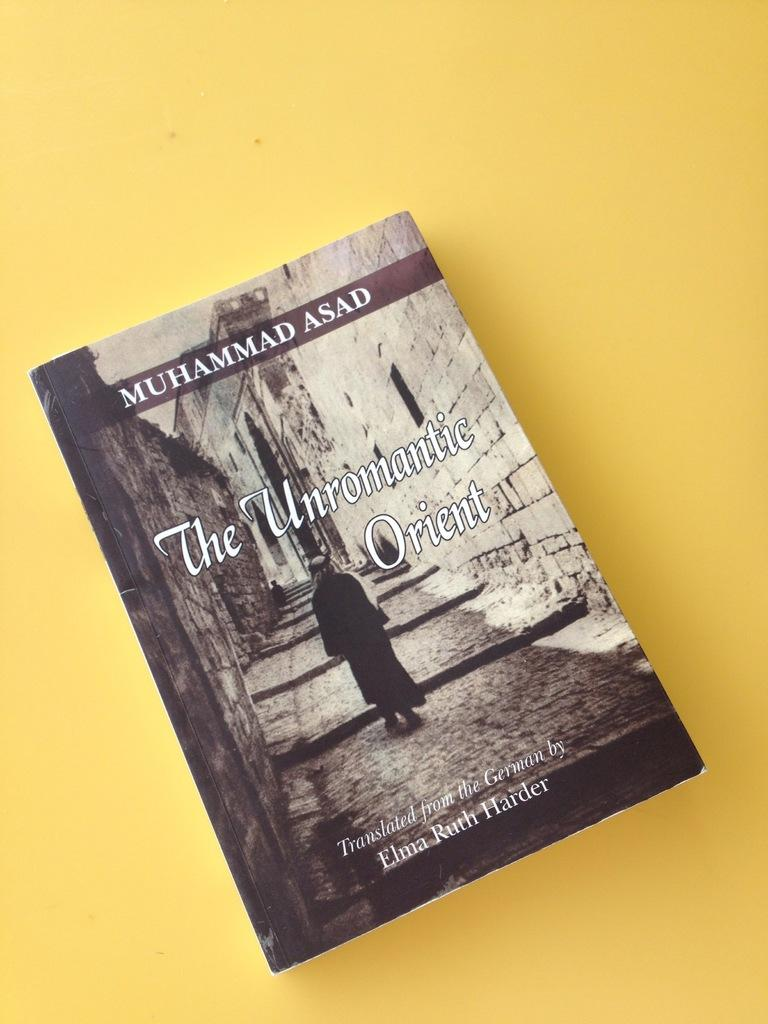<image>
Relay a brief, clear account of the picture shown. The Unromantic Orient written by Asad sits on a yellow background. 